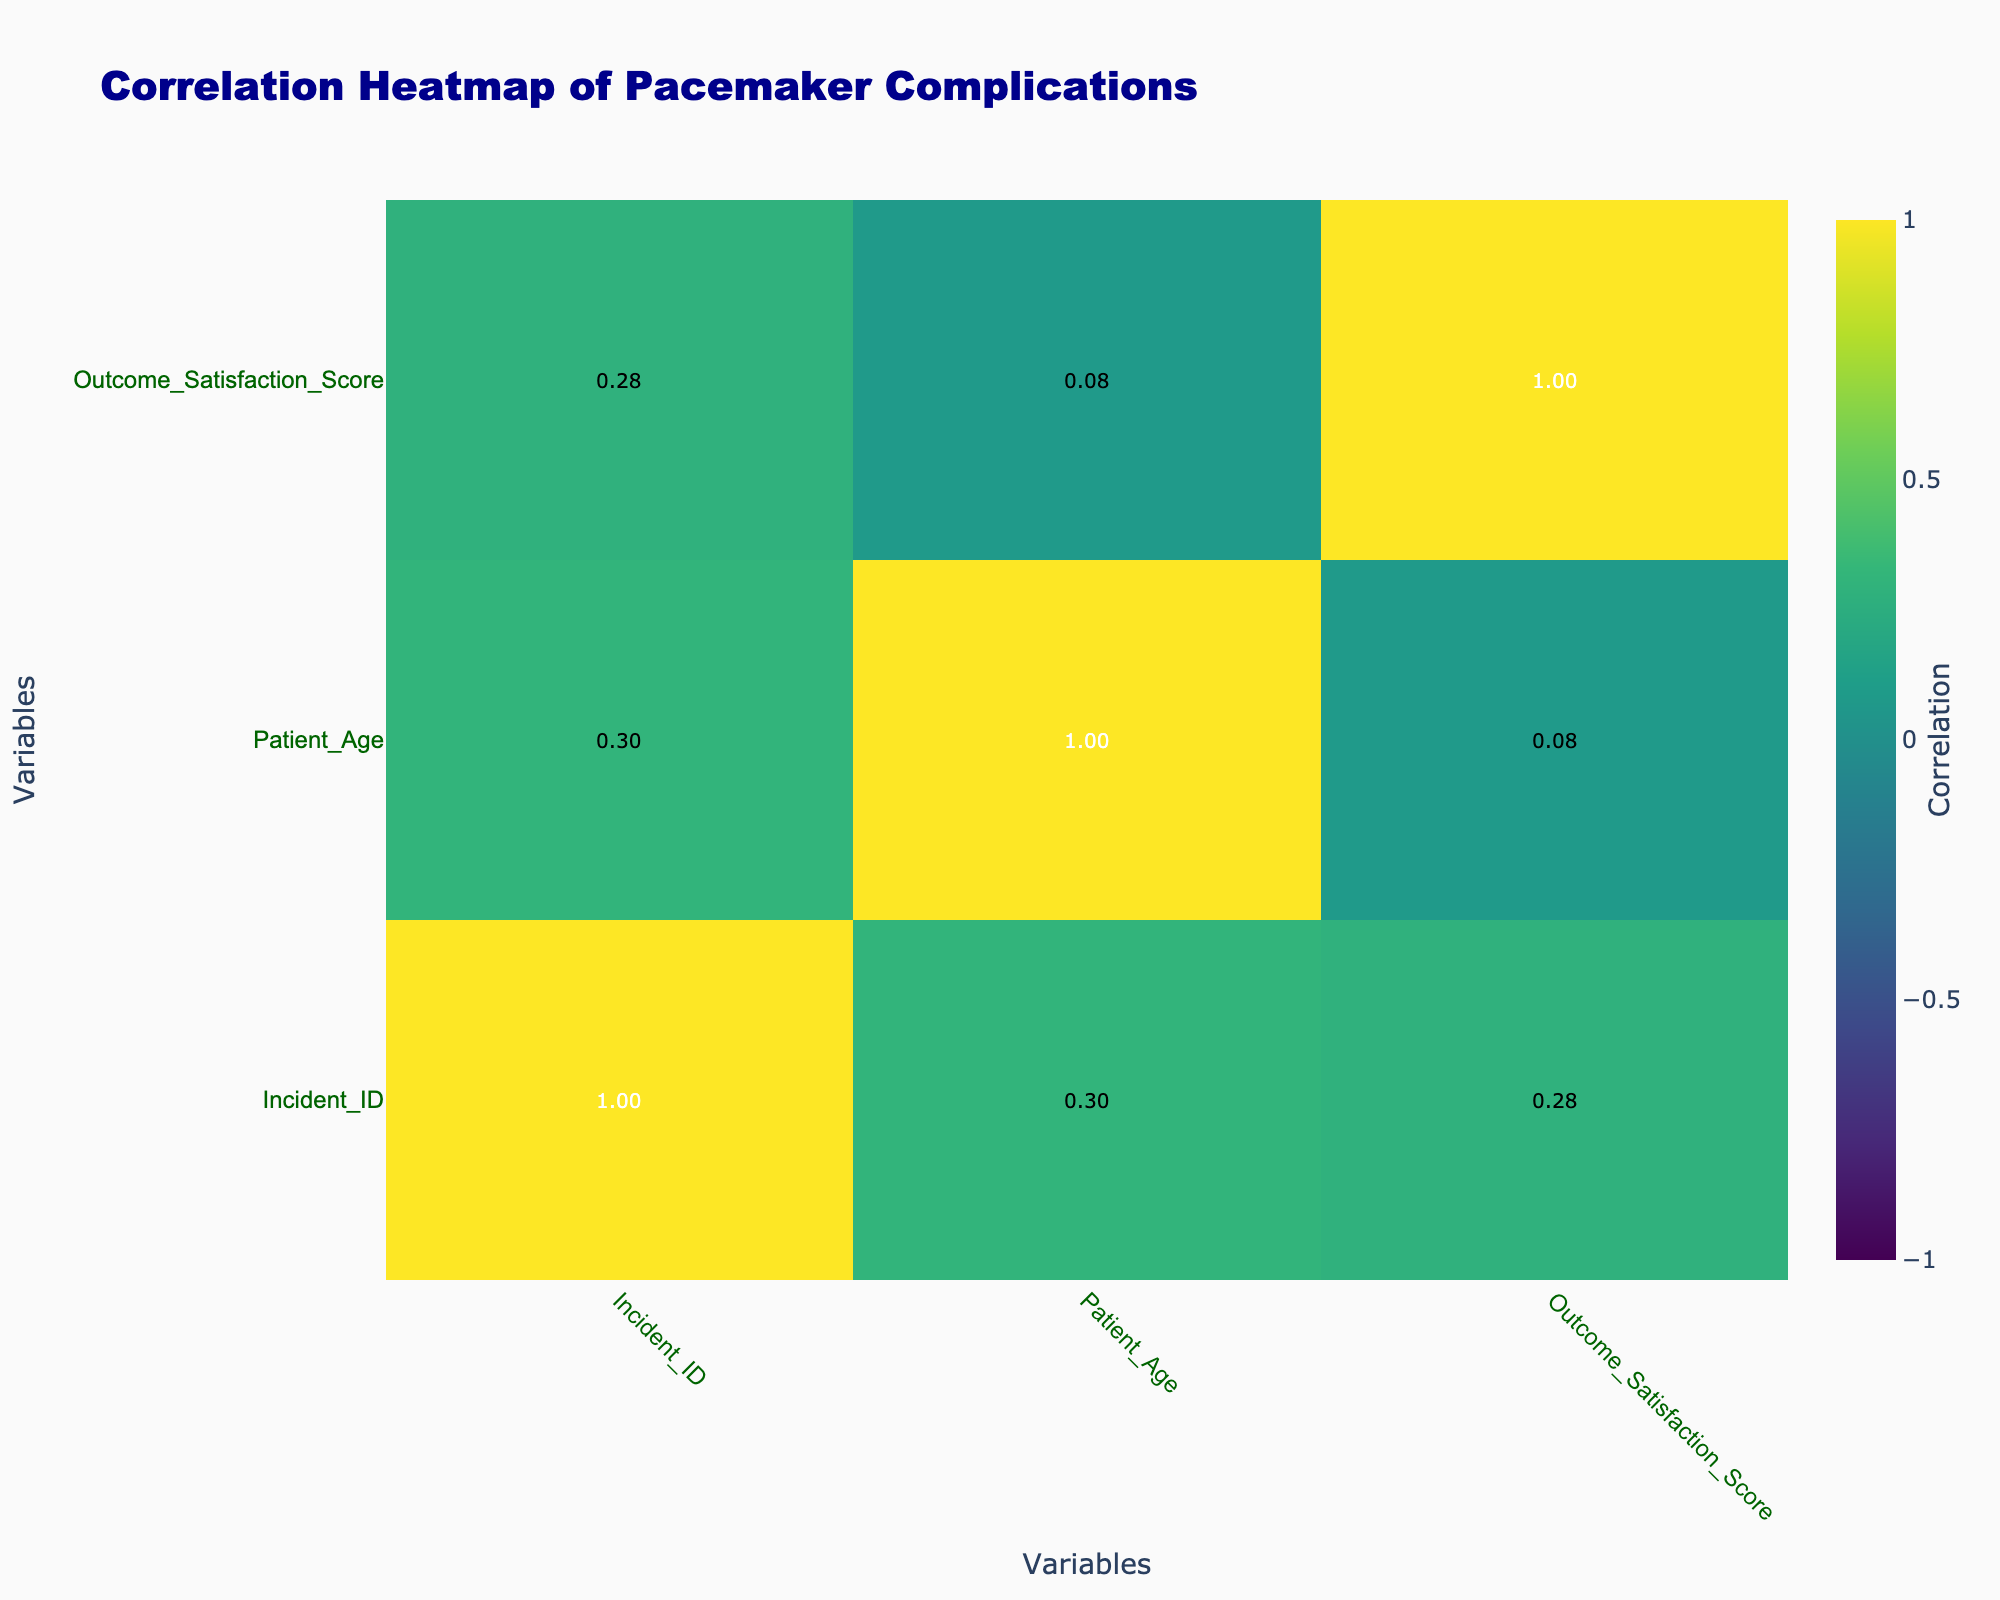What is the outcome satisfaction score for the patient with lead malfunction? The table shows that the patient with the complication of lead malfunction (Incident ID 1) has an outcome satisfaction score of 2.
Answer: 2 How many patients experienced hospital readmission due to complications? By reviewing the table, we see that there are 5 patients (Incident IDs 1, 3, 4, 6, and 9) who experienced hospital readmission for complications.
Answer: 5 Is there a correlation between the type of complication and the legal action taken? To determine this, we look at the "Legal Action Taken" column and correlate it with the "Complication Type." We can observe that 4 out of the 5 complications resulted in legal action, suggesting a positive correlation.
Answer: Yes What is the average outcome satisfaction score for patients who took legal action? We focus on the rows where "Legal Action Taken" is "Yes" (Incident IDs 1, 3, 4, 6, 7, and 10). The total satisfaction scores for these incidents are (2 + 3 + 1 + 2 + 3 + 5) = 16. There are 5 patients, so the average is 16/5 = 3.2.
Answer: 3.2 Did any patients with battery-related complications take legal action? By checking the data, we see that the patient with "Battery failure" (Incident ID 2) did not take legal action, while the patient with "Battery depletion" (Incident ID 7) did. Therefore, at least one patient took legal action.
Answer: Yes Which type of pacemaker had the highest satisfaction score among incidents? Analyzing the satisfaction scores for each pacemaker type, the Abbott Assurity scored 3 (Incident IDs 3 and 10), while the Boston Scientific INGEVITY scored 4 (Incident IDs 2 and 8). The Medtronic Advisa only has scores of 2 and 3. The highest satisfaction score of 5 belongs to the Boston Scientific ACCOLADE and Abbott Assurity (Incident ID 5 and 10, respectively), but Boston Scientific INGEVITY had the highest individual scores.
Answer: Boston Scientific INGEVITY How many patients with infections experienced a positive outcome satisfaction score (4 or 5)? We look specifically at Incident ID 3, which describes an infection, and the outcome satisfaction score is 3. No patients with infections scored 4 or 5.
Answer: 0 What is the difference between the highest and lowest satisfaction scores recorded? The highest satisfaction score is 5 (Incident ID 5 and 10), and the lowest is 1 (Incident ID 4). Hence, the difference is 5 - 1 = 4.
Answer: 4 How many patients aged over 75 experienced complications leading to hospital readmission? Checking the "Patient Age" and "Hospital Readmission" columns, we identify that patients aged 78, 80, and 82 had readmissions, resulting in 4 patients aged over 75 who experienced complications leading to readmission.
Answer: 4 